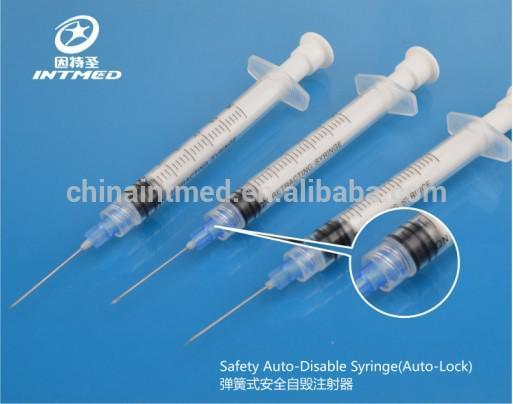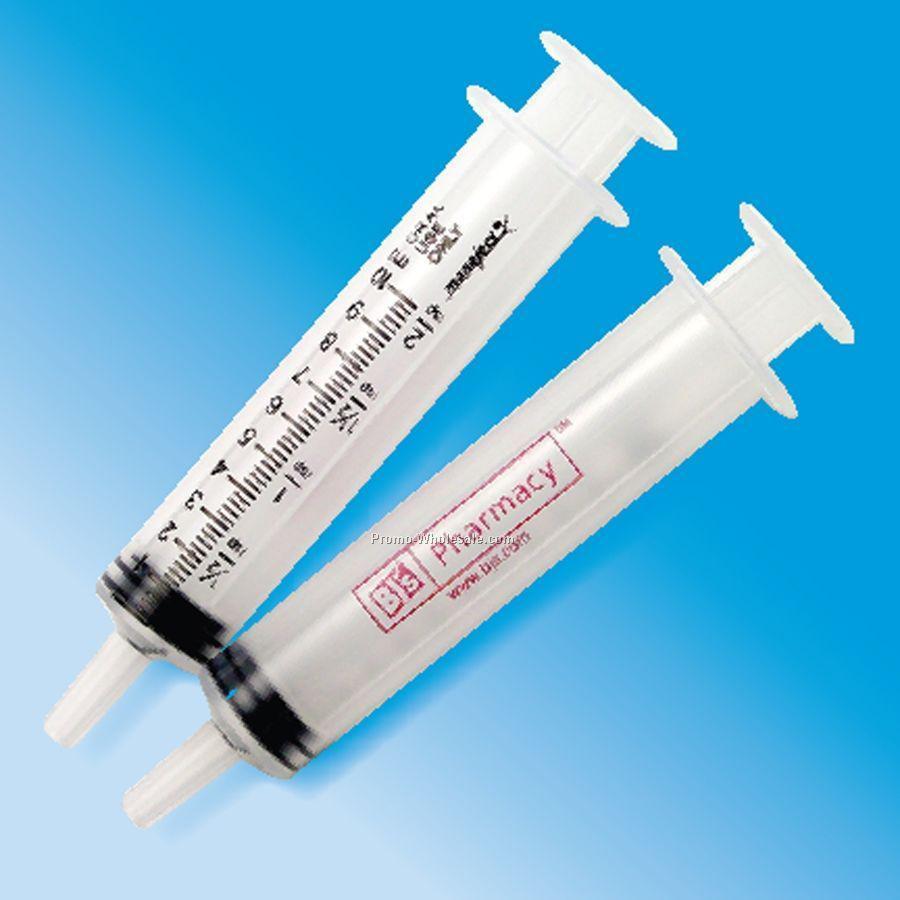The first image is the image on the left, the second image is the image on the right. Analyze the images presented: Is the assertion "One of the images contains more than five syringes." valid? Answer yes or no. No. The first image is the image on the left, the second image is the image on the right. Given the left and right images, does the statement "One image shows two unwrapped syringe items, arranged side-by-side at an angle." hold true? Answer yes or no. Yes. 